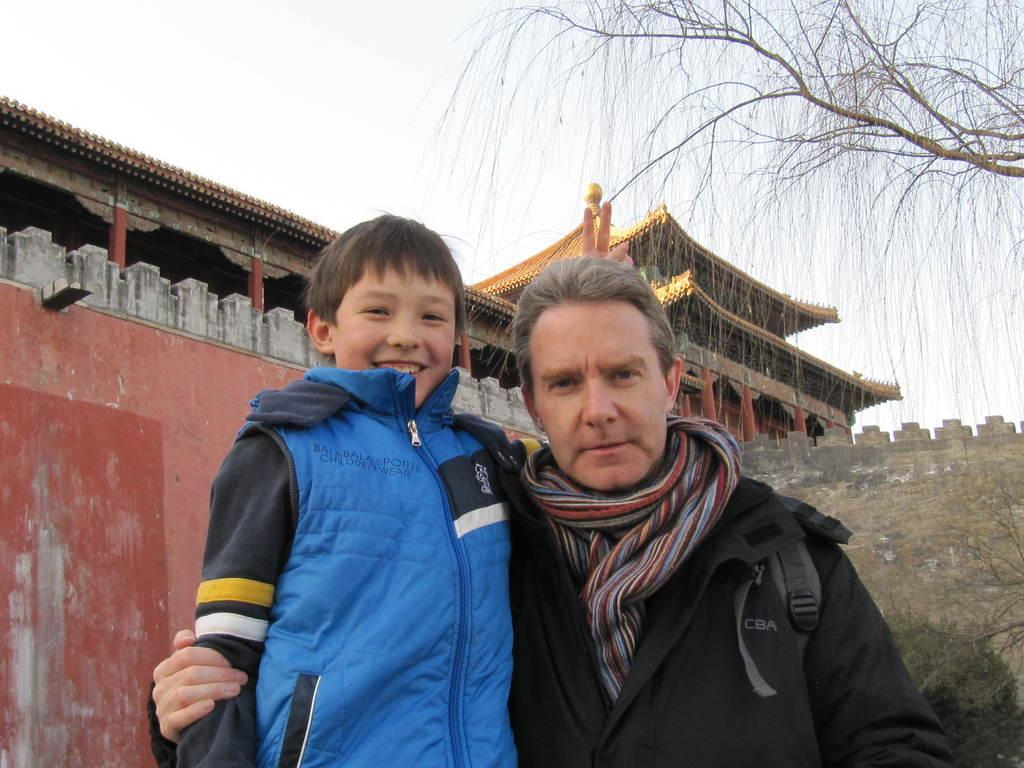How many people are in the image? There are two persons standing in the image. What are the people doing in the image? The persons are smiling. What can be seen in the background of the image? There are buildings and trees in the background of the image. What is visible at the top of the image? The sky is visible at the top of the image. Can you tell me how many cans are visible in the image? There are no cans present in the image. What type of frog can be seen sitting on the tree in the image? There is no frog or tree present in the image. 